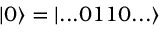<formula> <loc_0><loc_0><loc_500><loc_500>| 0 \rangle = | \dots 0 1 1 0 \dots \rangle</formula> 